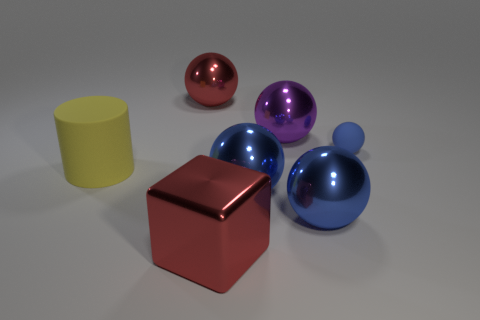Subtract all blue blocks. How many blue balls are left? 3 Subtract all purple balls. How many balls are left? 4 Subtract all small blue rubber spheres. How many spheres are left? 4 Subtract all green balls. Subtract all yellow cylinders. How many balls are left? 5 Add 3 metal cubes. How many objects exist? 10 Subtract all balls. How many objects are left? 2 Subtract all large purple shiny spheres. Subtract all metallic objects. How many objects are left? 1 Add 3 cylinders. How many cylinders are left? 4 Add 5 big spheres. How many big spheres exist? 9 Subtract 0 green blocks. How many objects are left? 7 